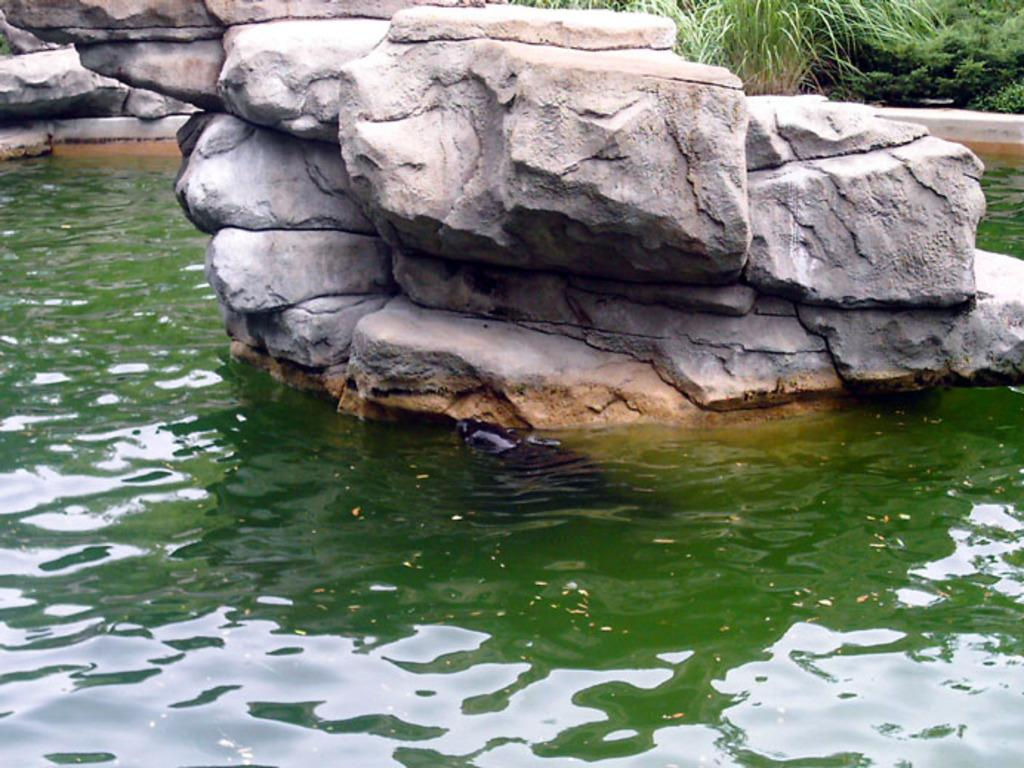What is floating on the surface of the water in the image? There is a rock on the surface of the water in the image. What type of vegetation can be seen in the image? There is grass in the top right corner of the image. Where is the swing located in the image? There is no swing present in the image. What type of exchange is taking place in the image? There is no exchange present in the image. 